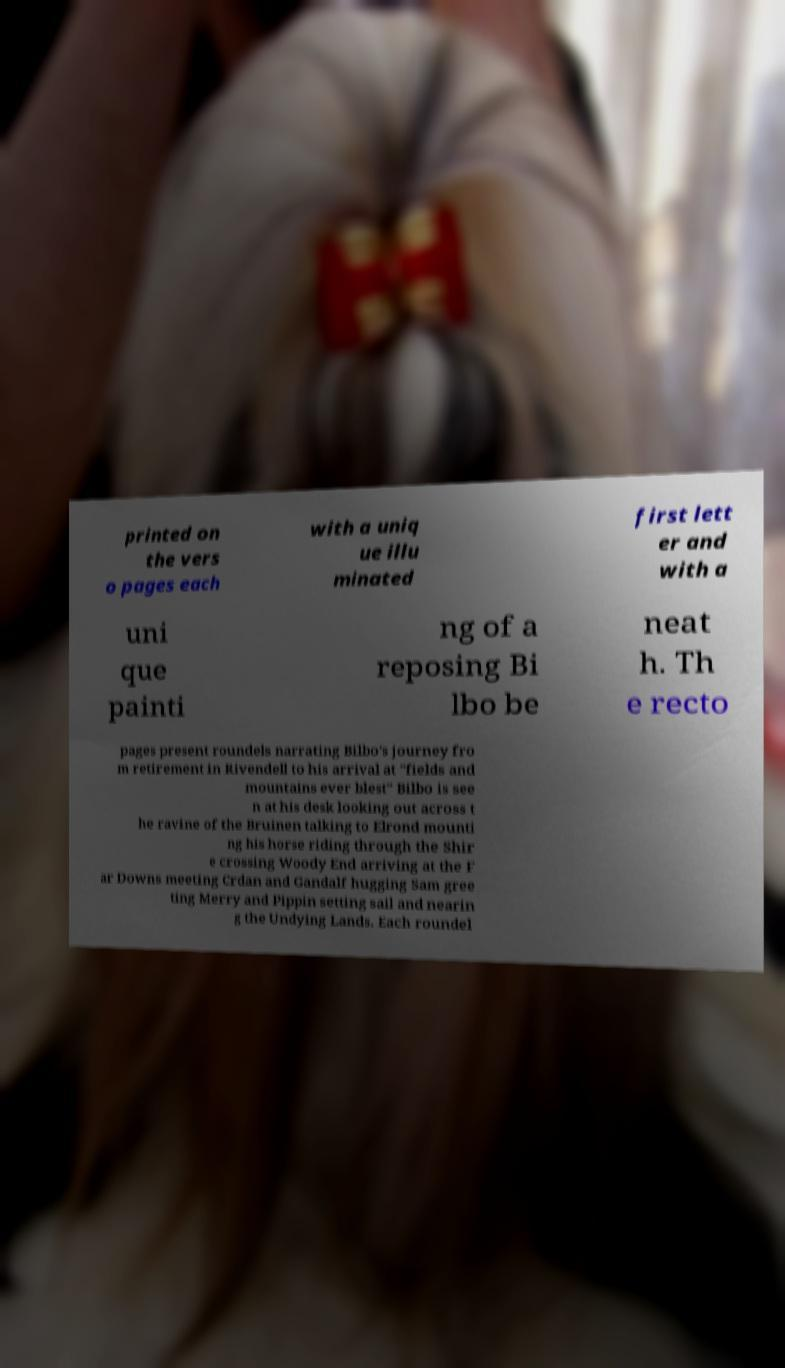Please identify and transcribe the text found in this image. printed on the vers o pages each with a uniq ue illu minated first lett er and with a uni que painti ng of a reposing Bi lbo be neat h. Th e recto pages present roundels narrating Bilbo's journey fro m retirement in Rivendell to his arrival at "fields and mountains ever blest" Bilbo is see n at his desk looking out across t he ravine of the Bruinen talking to Elrond mounti ng his horse riding through the Shir e crossing Woody End arriving at the F ar Downs meeting Crdan and Gandalf hugging Sam gree ting Merry and Pippin setting sail and nearin g the Undying Lands. Each roundel 